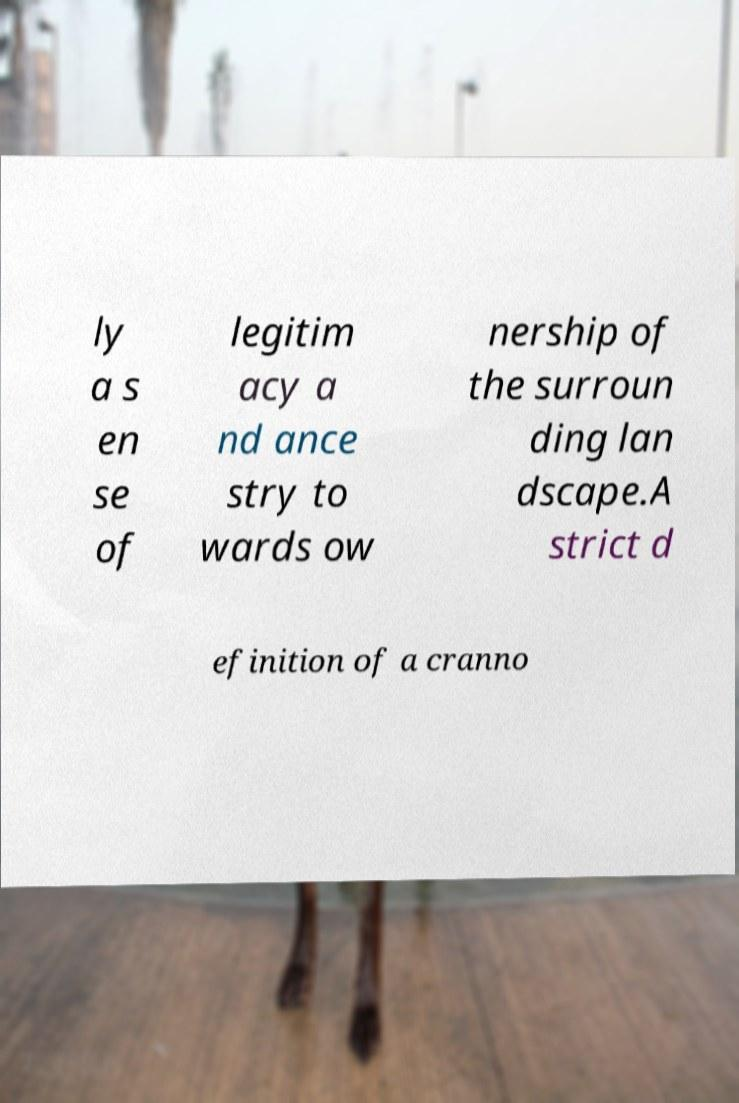I need the written content from this picture converted into text. Can you do that? ly a s en se of legitim acy a nd ance stry to wards ow nership of the surroun ding lan dscape.A strict d efinition of a cranno 